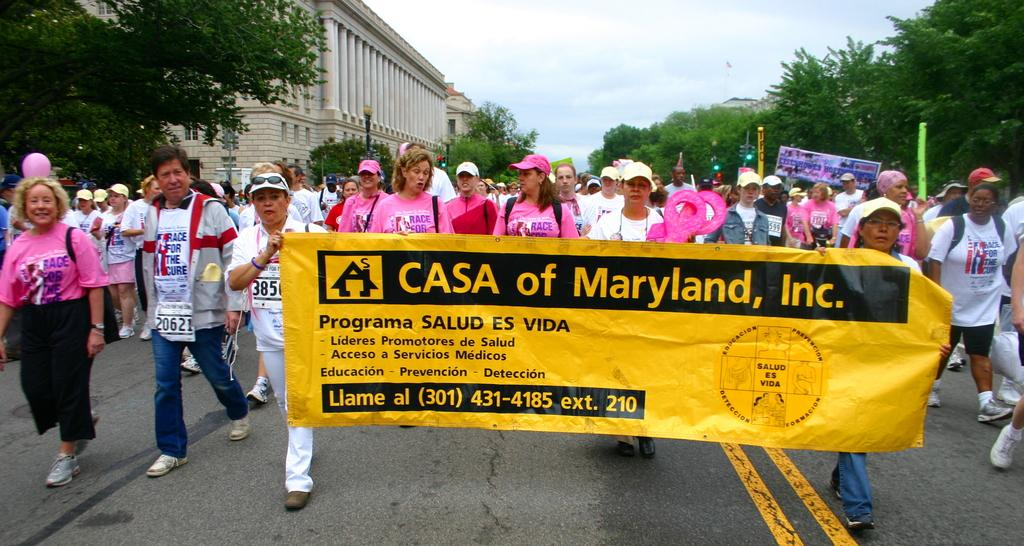What are the people in the foreground of the image doing? The people in the foreground of the image are holding a flex. What can be seen in the background of the image? There are trees, buildings, and poles in the background of the image. What is visible in the sky in the image? The sky is visible in the background of the image. How many children are waving good-bye on the page in the image? There are no children or pages present in the image; it features people holding a flex and a background with trees, buildings, poles, and the sky. 